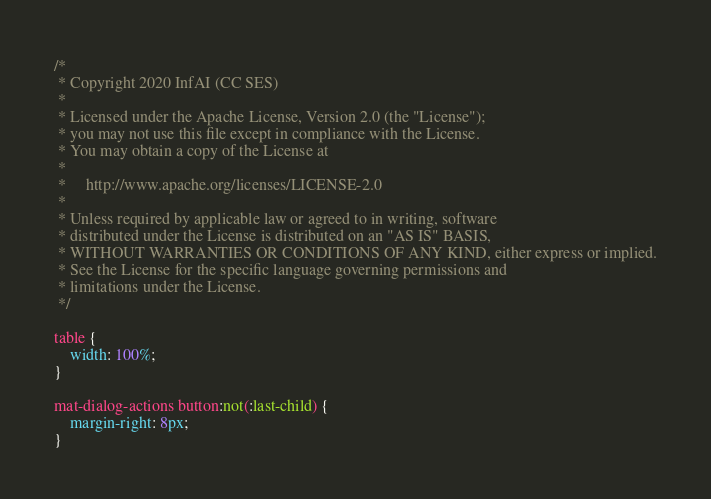<code> <loc_0><loc_0><loc_500><loc_500><_CSS_>/*
 * Copyright 2020 InfAI (CC SES)
 *
 * Licensed under the Apache License, Version 2.0 (the "License");
 * you may not use this file except in compliance with the License.
 * You may obtain a copy of the License at
 *
 *     http://www.apache.org/licenses/LICENSE-2.0
 *
 * Unless required by applicable law or agreed to in writing, software
 * distributed under the License is distributed on an "AS IS" BASIS,
 * WITHOUT WARRANTIES OR CONDITIONS OF ANY KIND, either express or implied.
 * See the License for the specific language governing permissions and
 * limitations under the License.
 */

table {
    width: 100%;
}

mat-dialog-actions button:not(:last-child) {
    margin-right: 8px;
}
</code> 